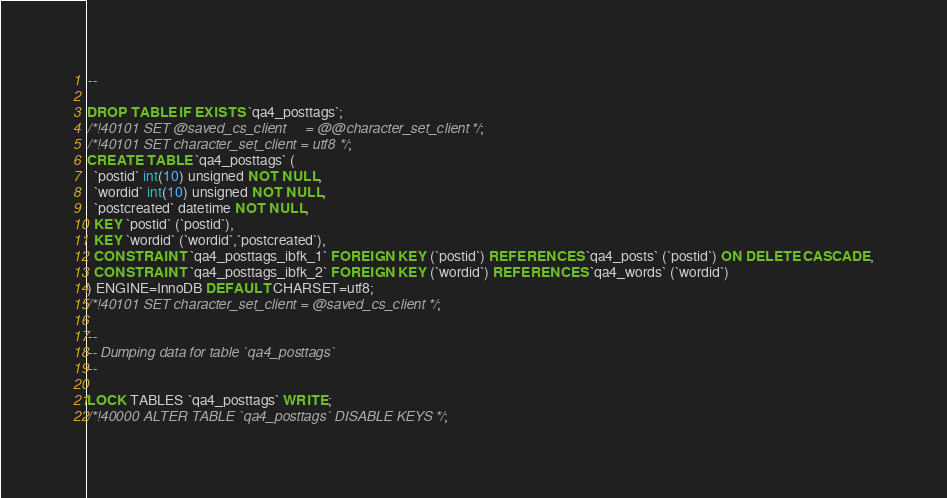Convert code to text. <code><loc_0><loc_0><loc_500><loc_500><_SQL_>--

DROP TABLE IF EXISTS `qa4_posttags`;
/*!40101 SET @saved_cs_client     = @@character_set_client */;
/*!40101 SET character_set_client = utf8 */;
CREATE TABLE `qa4_posttags` (
  `postid` int(10) unsigned NOT NULL,
  `wordid` int(10) unsigned NOT NULL,
  `postcreated` datetime NOT NULL,
  KEY `postid` (`postid`),
  KEY `wordid` (`wordid`,`postcreated`),
  CONSTRAINT `qa4_posttags_ibfk_1` FOREIGN KEY (`postid`) REFERENCES `qa4_posts` (`postid`) ON DELETE CASCADE,
  CONSTRAINT `qa4_posttags_ibfk_2` FOREIGN KEY (`wordid`) REFERENCES `qa4_words` (`wordid`)
) ENGINE=InnoDB DEFAULT CHARSET=utf8;
/*!40101 SET character_set_client = @saved_cs_client */;

--
-- Dumping data for table `qa4_posttags`
--

LOCK TABLES `qa4_posttags` WRITE;
/*!40000 ALTER TABLE `qa4_posttags` DISABLE KEYS */;</code> 